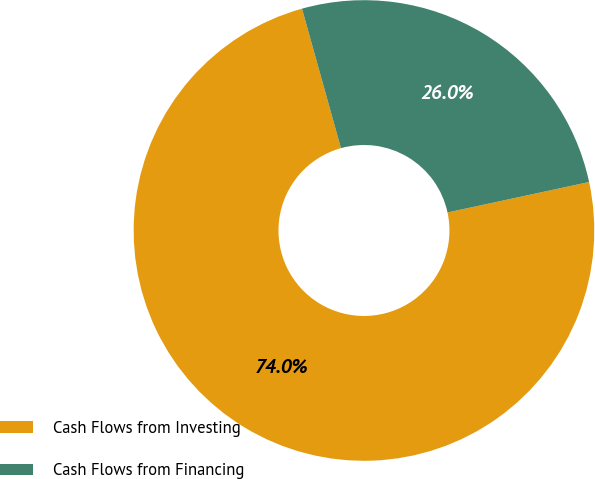Convert chart. <chart><loc_0><loc_0><loc_500><loc_500><pie_chart><fcel>Cash Flows from Investing<fcel>Cash Flows from Financing<nl><fcel>74.04%<fcel>25.96%<nl></chart> 